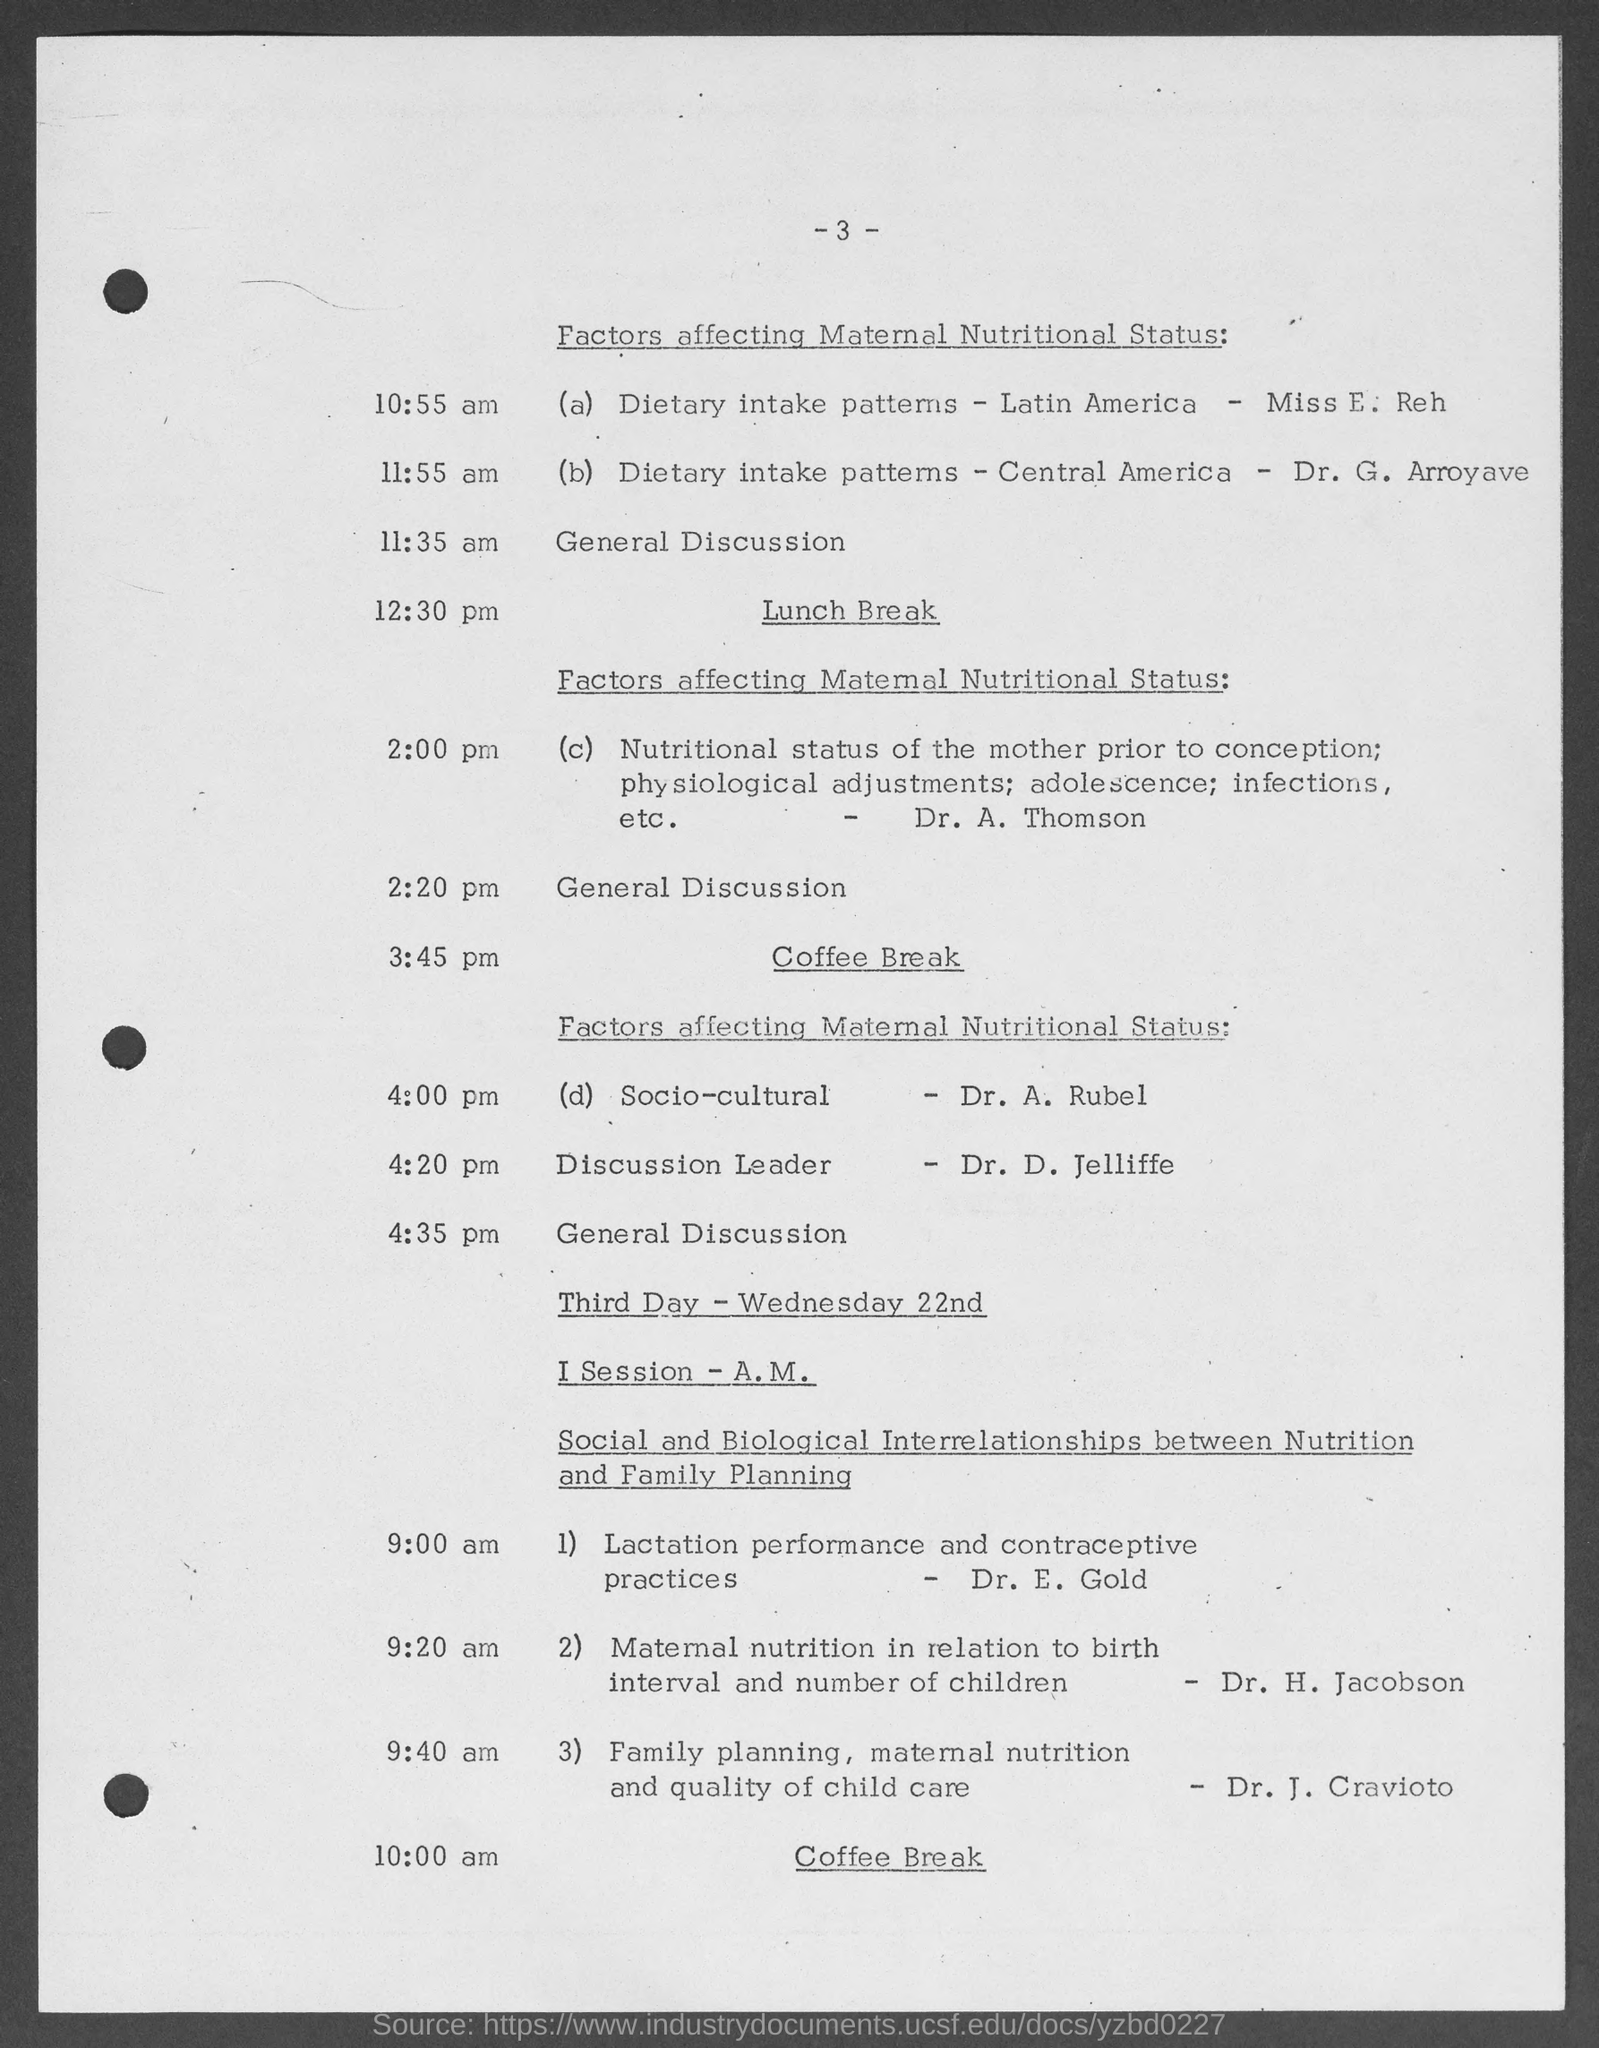Draw attention to some important aspects in this diagram. The coffee break on the third day is scheduled to take place at 10:00 am. After lunch, the topic of discussion was "Factors Affecting Maternal Nutritional Status. 